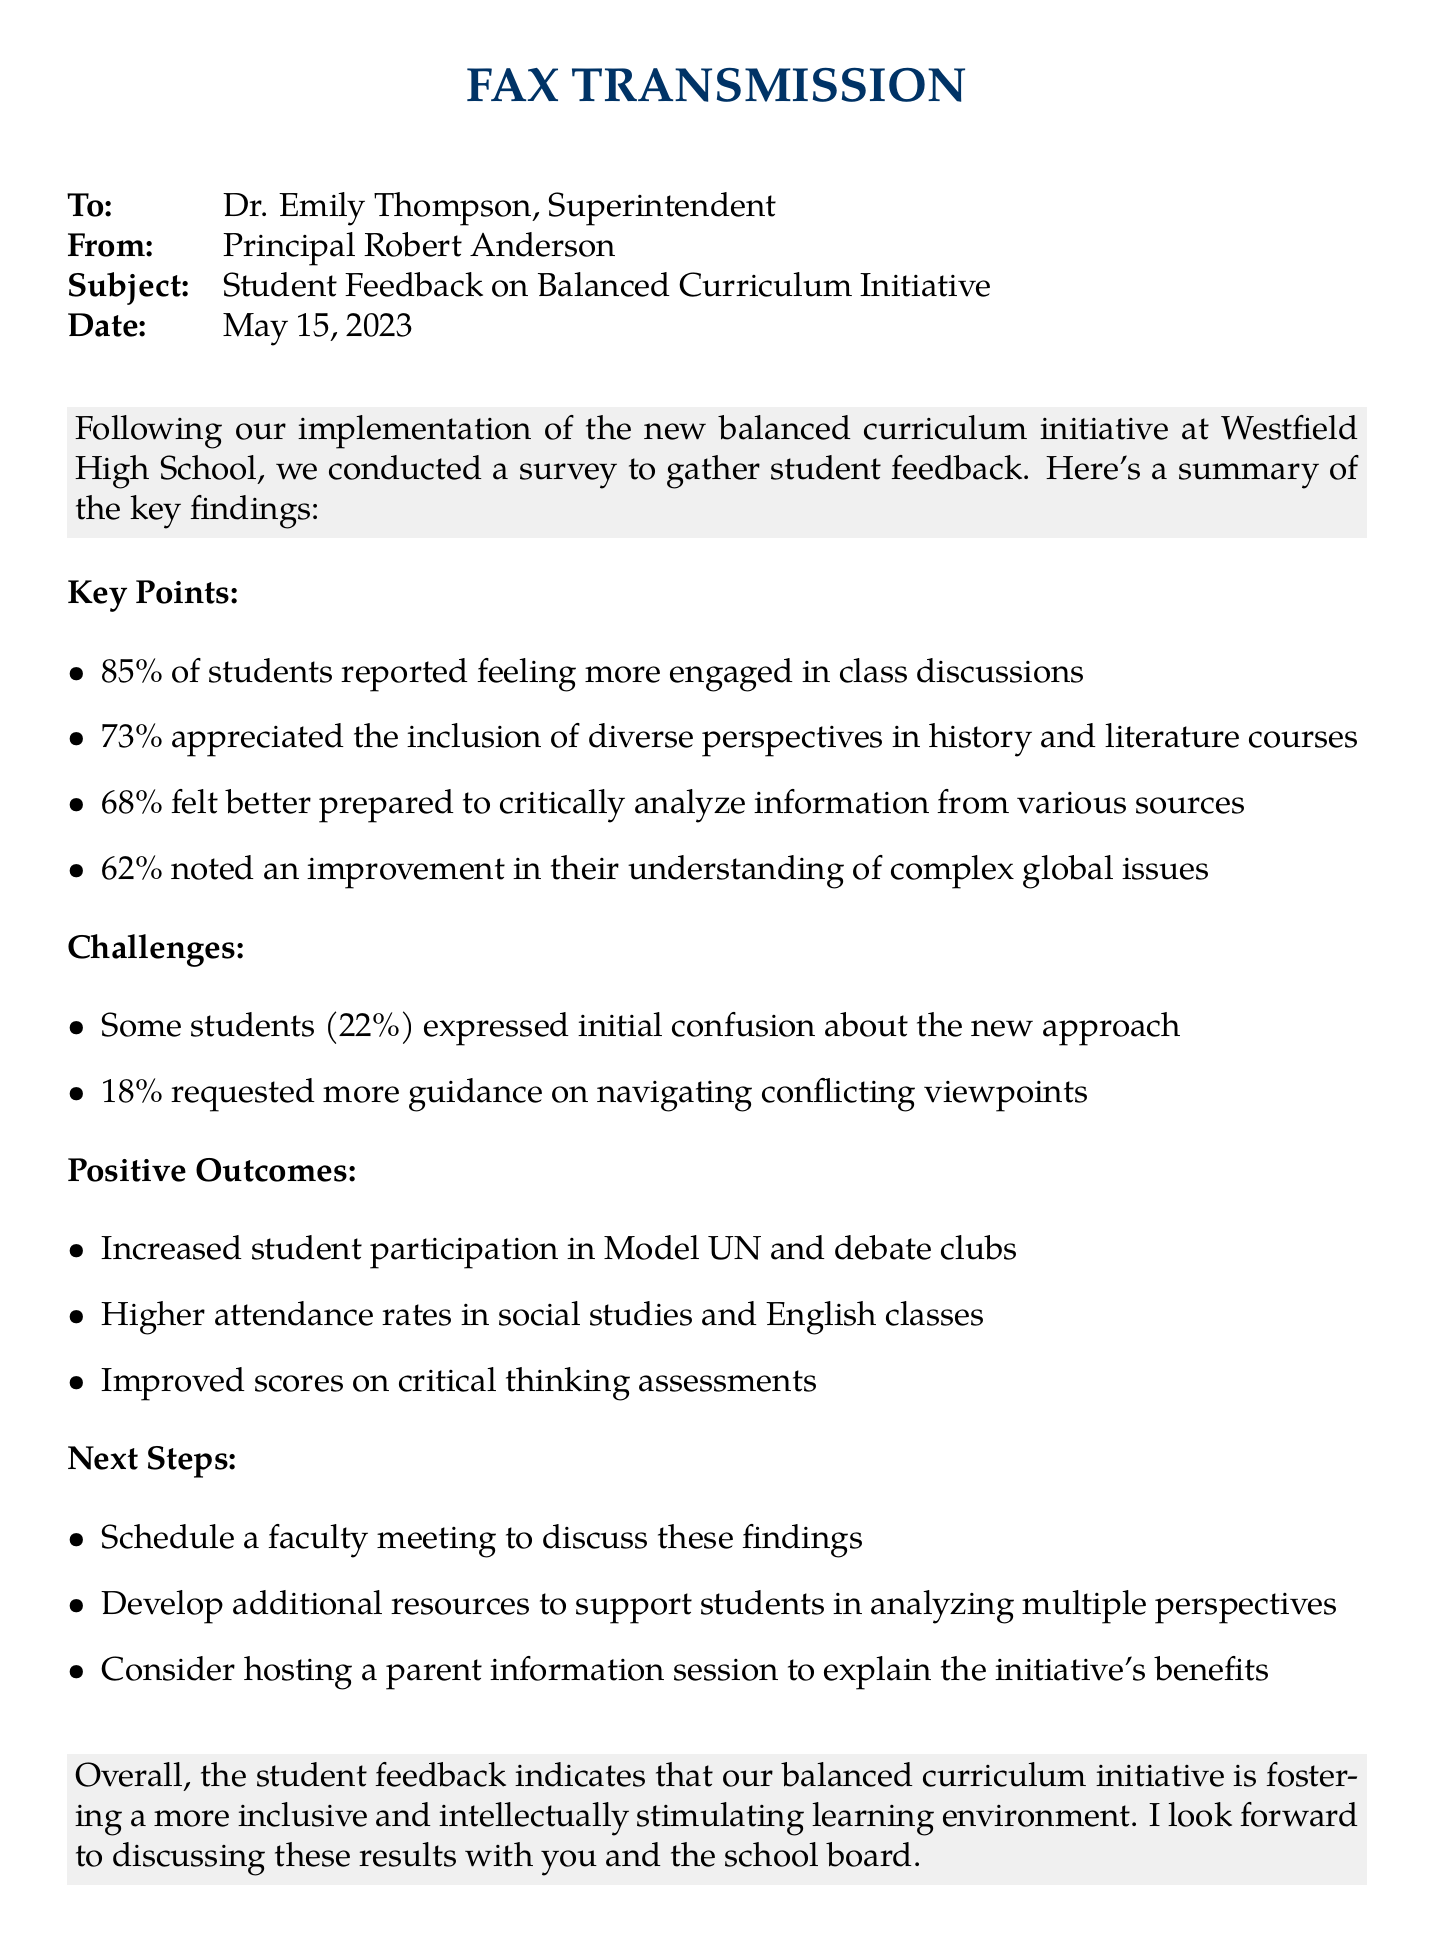What percentage of students feel more engaged in class discussions? The document states that 85% of students reported feeling more engaged in class discussions.
Answer: 85% How many students appreciated the inclusion of diverse perspectives? The document indicates that 73% appreciated the inclusion of diverse perspectives in history and literature courses.
Answer: 73% What is one challenge mentioned regarding the new approach? One challenge mentioned is that some students (22%) expressed initial confusion about the new approach.
Answer: Initial confusion How many positive outcomes are listed in the document? The document lists three positive outcomes related to the balanced curriculum initiative.
Answer: Three What is one of the next steps proposed? One next step is to schedule a faculty meeting to discuss these findings.
Answer: Schedule a faculty meeting What date was the fax sent? The document shows the fax was sent on May 15, 2023.
Answer: May 15, 2023 What percentage of students felt better prepared to analyze information? The document states that 68% felt better prepared to critically analyze information from various sources.
Answer: 68% What is the overall sentiment regarding the curriculum initiative? The overall sentiment in the document suggests that the initiative is fostering a more inclusive and intellectually stimulating learning environment.
Answer: Inclusive environment 